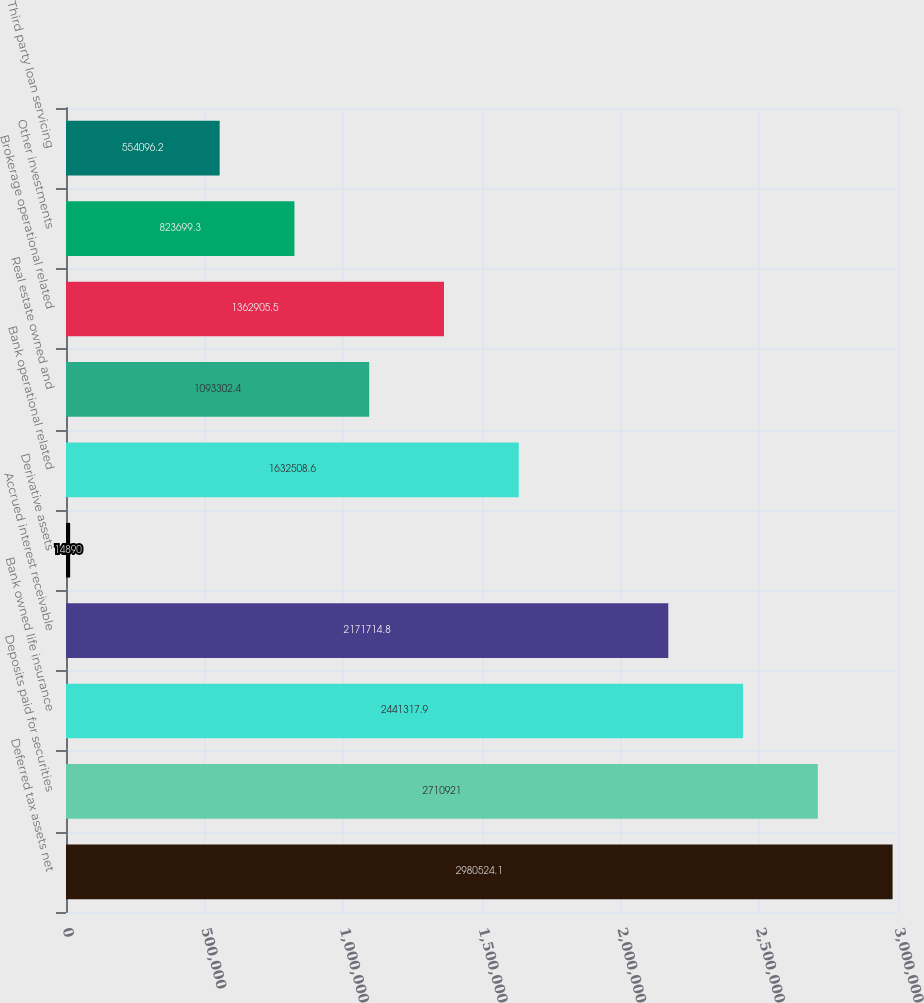<chart> <loc_0><loc_0><loc_500><loc_500><bar_chart><fcel>Deferred tax assets net<fcel>Deposits paid for securities<fcel>Bank owned life insurance<fcel>Accrued interest receivable<fcel>Derivative assets<fcel>Bank operational related<fcel>Real estate owned and<fcel>Brokerage operational related<fcel>Other investments<fcel>Third party loan servicing<nl><fcel>2.98052e+06<fcel>2.71092e+06<fcel>2.44132e+06<fcel>2.17171e+06<fcel>14890<fcel>1.63251e+06<fcel>1.0933e+06<fcel>1.36291e+06<fcel>823699<fcel>554096<nl></chart> 